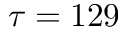Convert formula to latex. <formula><loc_0><loc_0><loc_500><loc_500>\tau = 1 2 9</formula> 